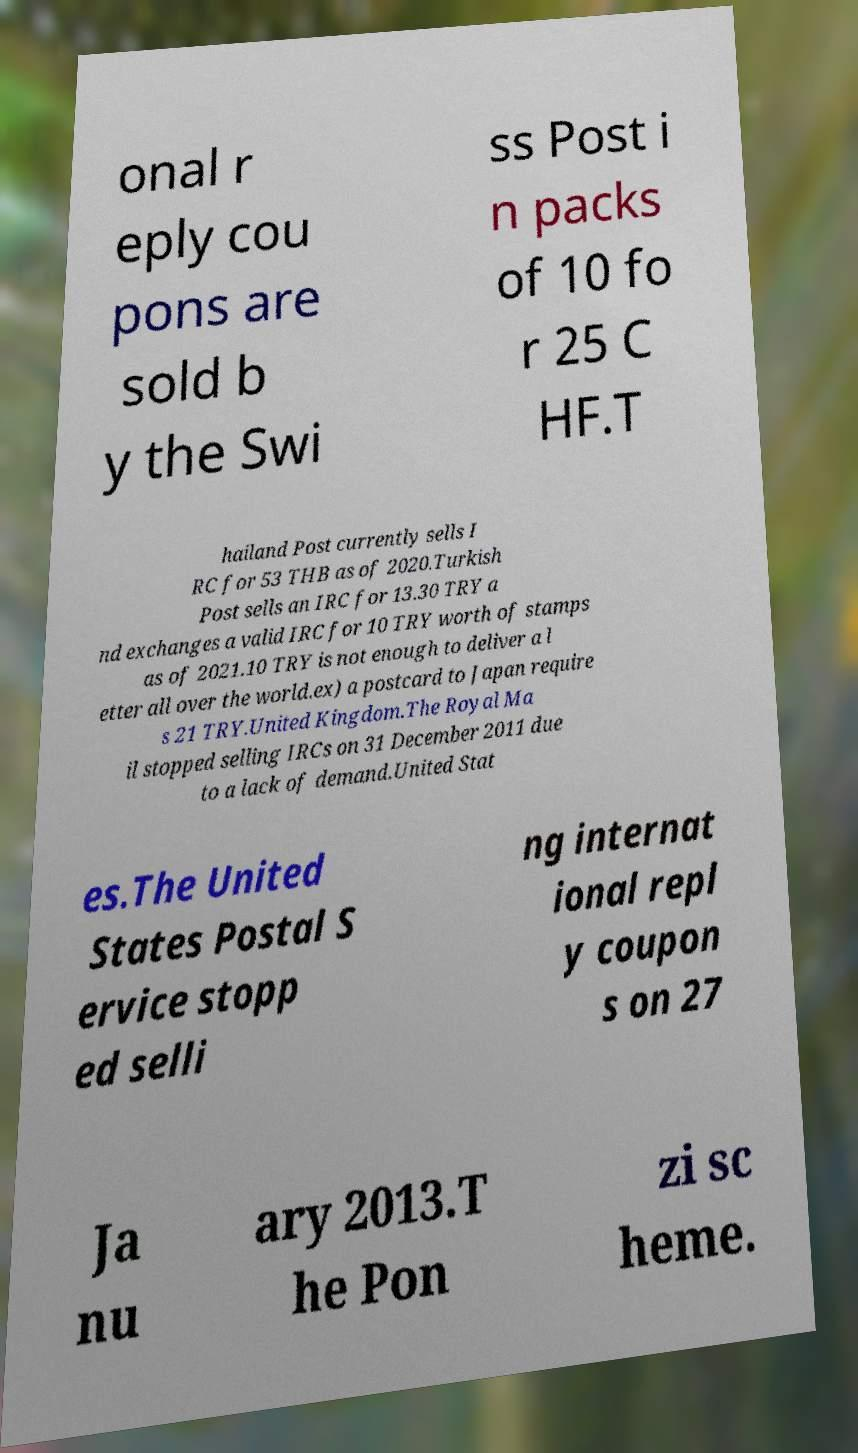Can you read and provide the text displayed in the image?This photo seems to have some interesting text. Can you extract and type it out for me? onal r eply cou pons are sold b y the Swi ss Post i n packs of 10 fo r 25 C HF.T hailand Post currently sells I RC for 53 THB as of 2020.Turkish Post sells an IRC for 13.30 TRY a nd exchanges a valid IRC for 10 TRY worth of stamps as of 2021.10 TRY is not enough to deliver a l etter all over the world.ex) a postcard to Japan require s 21 TRY.United Kingdom.The Royal Ma il stopped selling IRCs on 31 December 2011 due to a lack of demand.United Stat es.The United States Postal S ervice stopp ed selli ng internat ional repl y coupon s on 27 Ja nu ary 2013.T he Pon zi sc heme. 